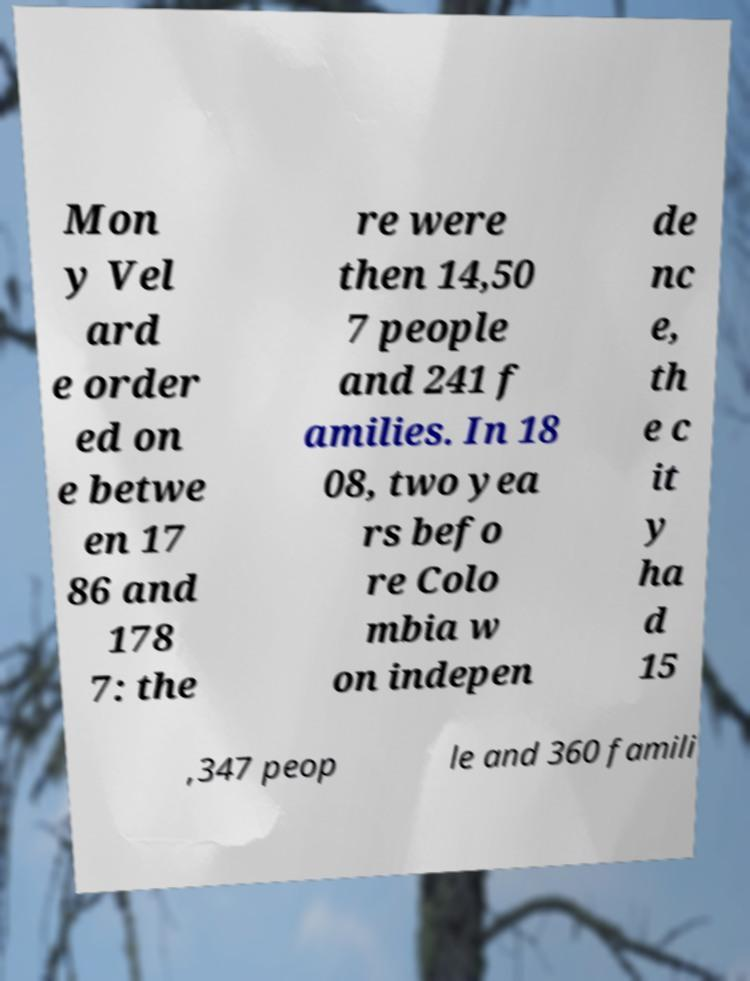Can you read and provide the text displayed in the image?This photo seems to have some interesting text. Can you extract and type it out for me? Mon y Vel ard e order ed on e betwe en 17 86 and 178 7: the re were then 14,50 7 people and 241 f amilies. In 18 08, two yea rs befo re Colo mbia w on indepen de nc e, th e c it y ha d 15 ,347 peop le and 360 famili 